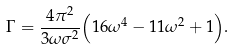Convert formula to latex. <formula><loc_0><loc_0><loc_500><loc_500>\Gamma = { \frac { 4 \pi ^ { 2 } } { 3 \omega \sigma ^ { 2 } } } { \left ( 1 6 \omega ^ { 4 } - 1 1 \omega ^ { 2 } + 1 \right ) } .</formula> 